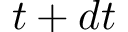Convert formula to latex. <formula><loc_0><loc_0><loc_500><loc_500>t + d t</formula> 